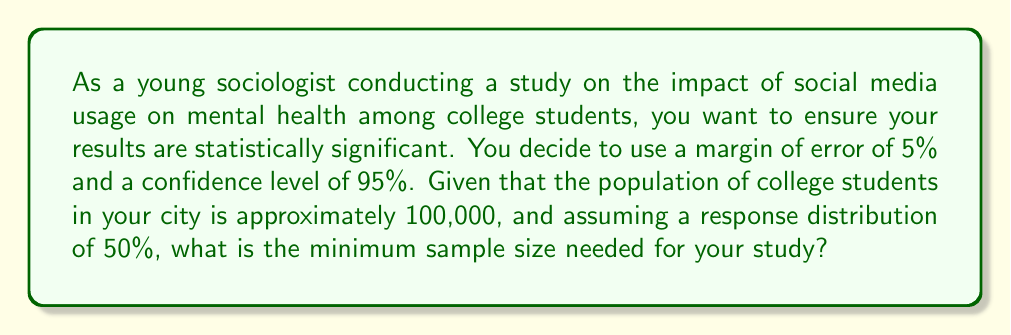Can you answer this question? To determine the sample size for a statistically significant study, we can use the following formula:

$$n = \frac{N \cdot Z^2 \cdot p(1-p)}{(N-1) \cdot e^2 + Z^2 \cdot p(1-p)}$$

Where:
$n$ = Sample size
$N$ = Population size (100,000)
$Z$ = Z-score (1.96 for 95% confidence level)
$e$ = Margin of error (0.05 or 5%)
$p$ = Response distribution (0.5 or 50%)

Step 1: Plug in the values into the formula
$$n = \frac{100000 \cdot 1.96^2 \cdot 0.5(1-0.5)}{(100000-1) \cdot 0.05^2 + 1.96^2 \cdot 0.5(1-0.5)}$$

Step 2: Simplify the numerator
$$n = \frac{100000 \cdot 3.8416 \cdot 0.25}{99999 \cdot 0.0025 + 3.8416 \cdot 0.25}$$

Step 3: Calculate the numerator and denominator separately
Numerator: $100000 \cdot 3.8416 \cdot 0.25 = 96040$
Denominator: $(99999 \cdot 0.0025) + (3.8416 \cdot 0.25) = 249.9975 + 0.9604 = 250.9579$

Step 4: Divide the numerator by the denominator
$$n = \frac{96040}{250.9579} = 382.6959$$

Step 5: Round up to the nearest whole number, as we can't have a fractional sample size.

Therefore, the minimum sample size needed is 383.
Answer: 383 participants 